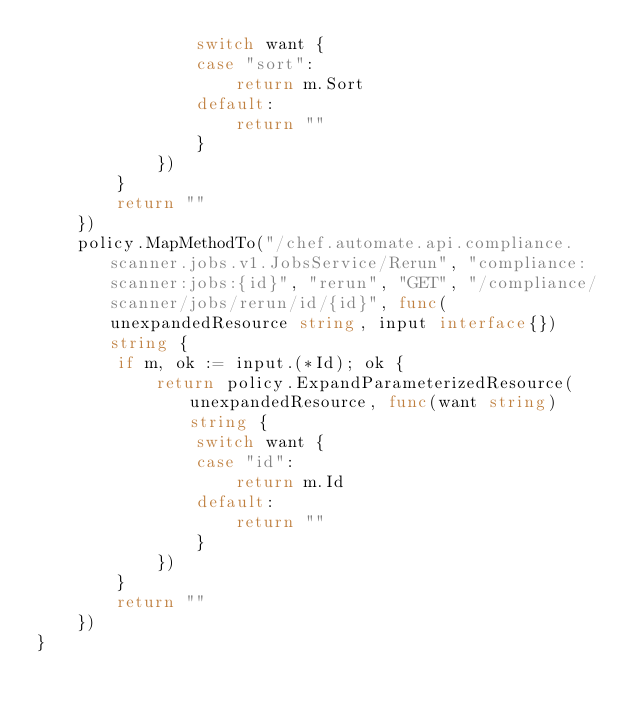Convert code to text. <code><loc_0><loc_0><loc_500><loc_500><_Go_>				switch want {
				case "sort":
					return m.Sort
				default:
					return ""
				}
			})
		}
		return ""
	})
	policy.MapMethodTo("/chef.automate.api.compliance.scanner.jobs.v1.JobsService/Rerun", "compliance:scanner:jobs:{id}", "rerun", "GET", "/compliance/scanner/jobs/rerun/id/{id}", func(unexpandedResource string, input interface{}) string {
		if m, ok := input.(*Id); ok {
			return policy.ExpandParameterizedResource(unexpandedResource, func(want string) string {
				switch want {
				case "id":
					return m.Id
				default:
					return ""
				}
			})
		}
		return ""
	})
}
</code> 